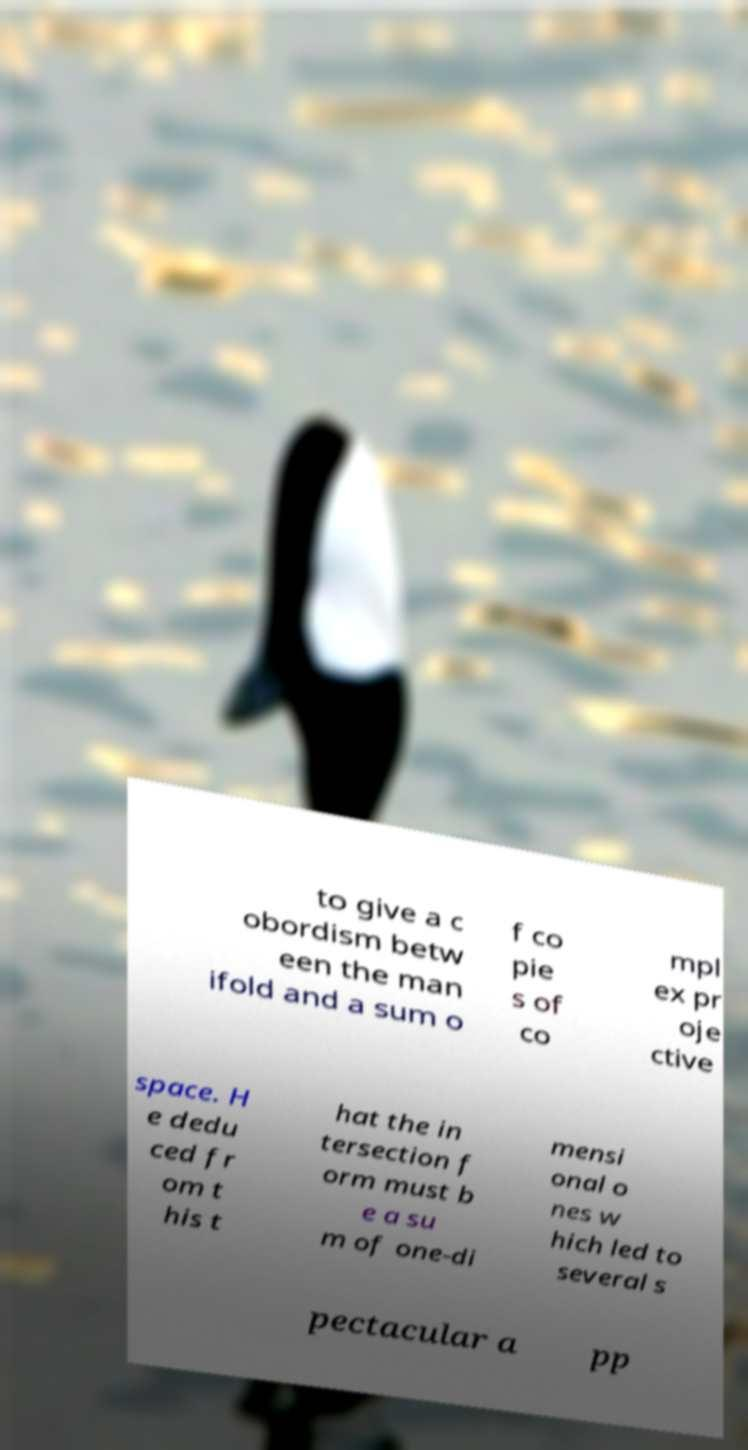There's text embedded in this image that I need extracted. Can you transcribe it verbatim? to give a c obordism betw een the man ifold and a sum o f co pie s of co mpl ex pr oje ctive space. H e dedu ced fr om t his t hat the in tersection f orm must b e a su m of one-di mensi onal o nes w hich led to several s pectacular a pp 